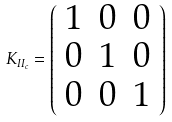Convert formula to latex. <formula><loc_0><loc_0><loc_500><loc_500>K _ { I I _ { c } } = \left ( \begin{array} { c c c } 1 & 0 & 0 \\ 0 & 1 & 0 \\ 0 & 0 & 1 \end{array} \right )</formula> 